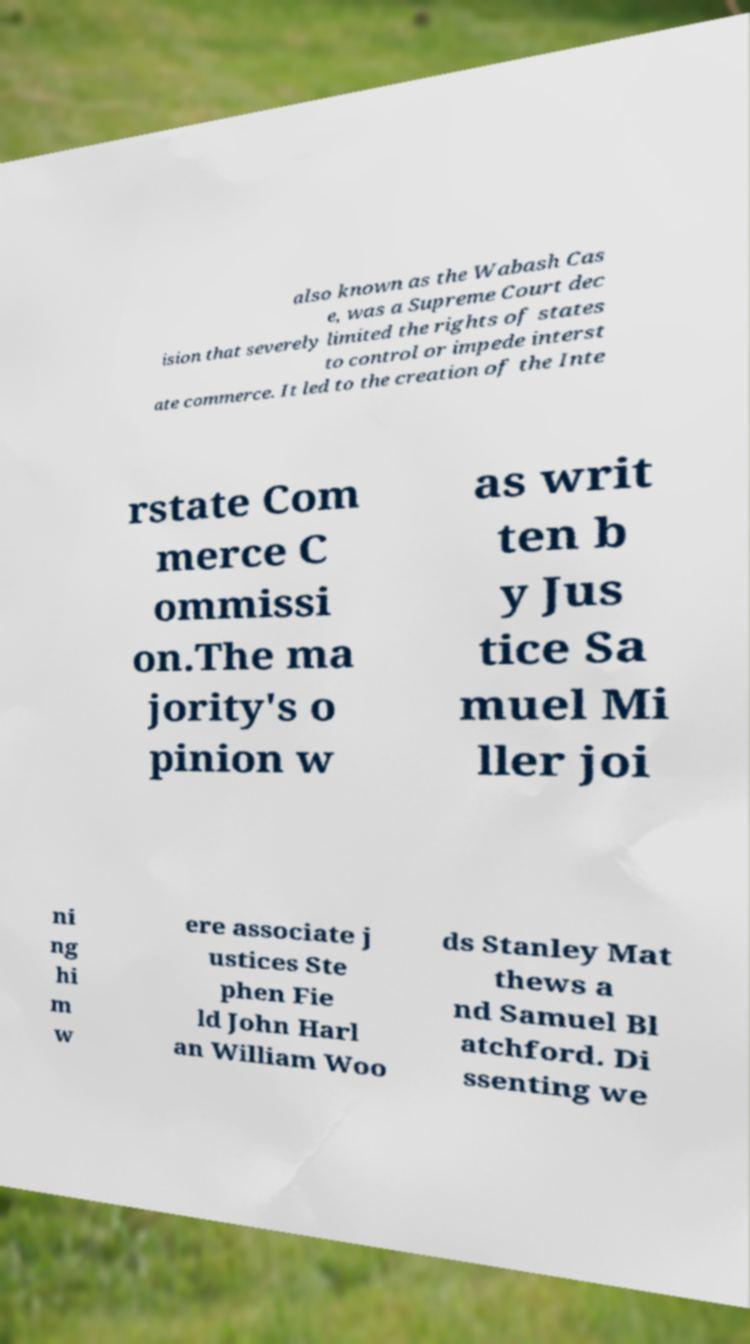Can you read and provide the text displayed in the image?This photo seems to have some interesting text. Can you extract and type it out for me? also known as the Wabash Cas e, was a Supreme Court dec ision that severely limited the rights of states to control or impede interst ate commerce. It led to the creation of the Inte rstate Com merce C ommissi on.The ma jority's o pinion w as writ ten b y Jus tice Sa muel Mi ller joi ni ng hi m w ere associate j ustices Ste phen Fie ld John Harl an William Woo ds Stanley Mat thews a nd Samuel Bl atchford. Di ssenting we 